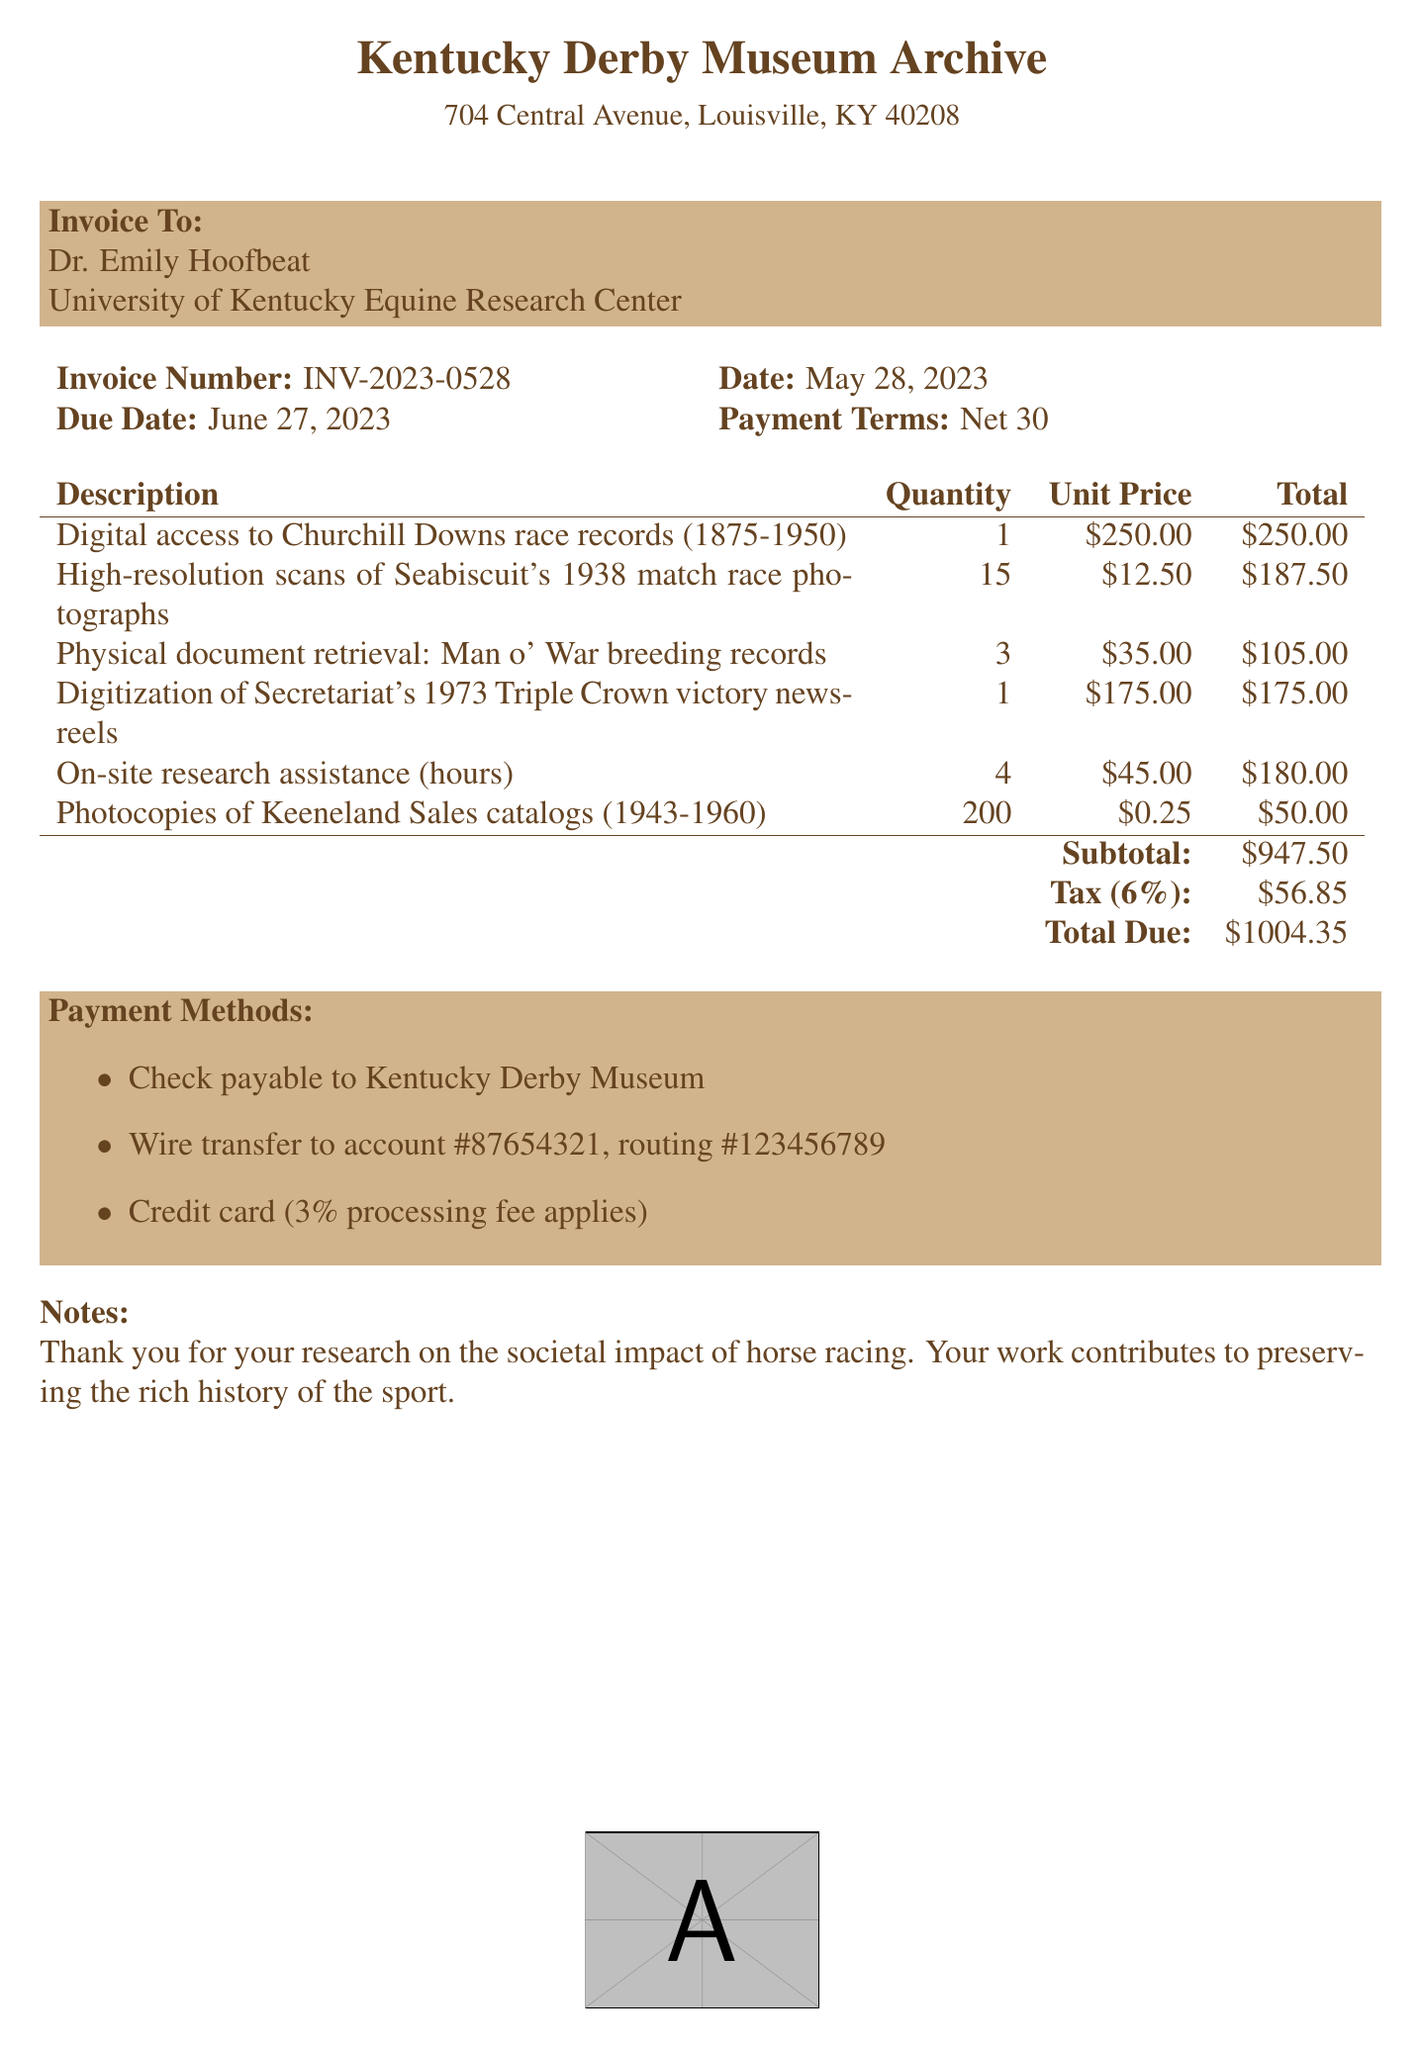what is the invoice number? The invoice number is listed at the top of the document and is a key identifier for this transaction.
Answer: INV-2023-0528 who is the researcher? The researcher's name is provided in the invoice, indicating who is responsible for the payment.
Answer: Dr. Emily Hoofbeat what is the total due amount? The total due is calculated from the subtotal plus tax, which is presented in the summary section of the document.
Answer: $1004.35 how many photocopies of the Keeneland Sales catalogs were requested? The quantity of photocopies is specified in the itemized list of services, highlighting how many were retrieved.
Answer: 200 what is the tax rate applied on the invoice? The tax rate is mentioned in the calculation section of the invoice, which indicates the applicable percentage for tax.
Answer: 6% what is the due date for the payment? The due date is specified next to the date of the invoice, indicating when the payment must be made.
Answer: June 27, 2023 how many hours of on-site research assistance were billed? The invoice includes the quantity of assistance hours in the itemized section, indicating the amount charged.
Answer: 4 what payment methods are accepted? The payment methods are listed towards the bottom of the invoice, detailing various options for payment.
Answer: Check, Wire transfer, Credit card what is the subtotal amount before tax? The subtotal is the sum of all itemized charges before any tax is added, and is clearly indicated in the document.
Answer: $947.50 what institution is Dr. Emily Hoofbeat affiliated with? The institution is provided in the invoice, identifying where the researcher is based for their work.
Answer: University of Kentucky Equine Research Center 